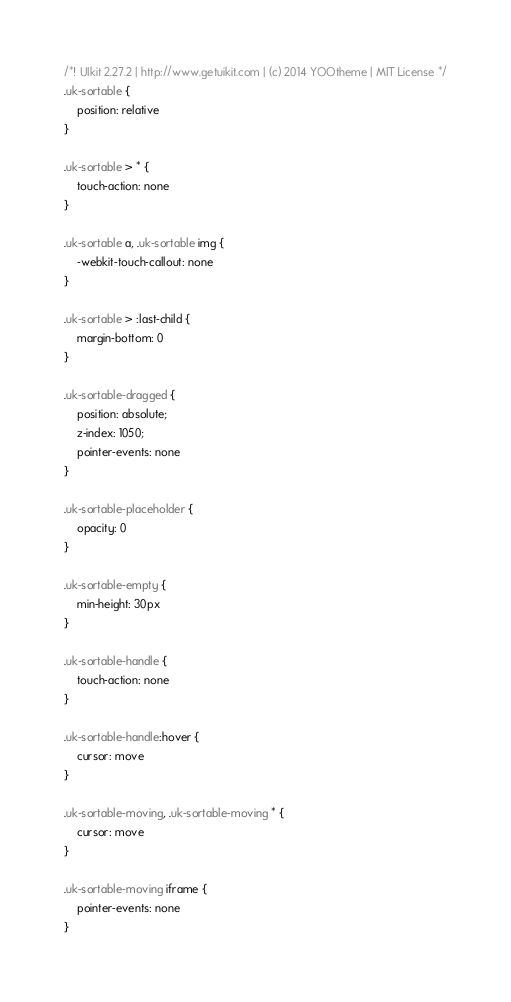<code> <loc_0><loc_0><loc_500><loc_500><_CSS_>/*! UIkit 2.27.2 | http://www.getuikit.com | (c) 2014 YOOtheme | MIT License */
.uk-sortable {
    position: relative
}

.uk-sortable > * {
    touch-action: none
}

.uk-sortable a, .uk-sortable img {
    -webkit-touch-callout: none
}

.uk-sortable > :last-child {
    margin-bottom: 0
}

.uk-sortable-dragged {
    position: absolute;
    z-index: 1050;
    pointer-events: none
}

.uk-sortable-placeholder {
    opacity: 0
}

.uk-sortable-empty {
    min-height: 30px
}

.uk-sortable-handle {
    touch-action: none
}

.uk-sortable-handle:hover {
    cursor: move
}

.uk-sortable-moving, .uk-sortable-moving * {
    cursor: move
}

.uk-sortable-moving iframe {
    pointer-events: none
}</code> 